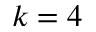Convert formula to latex. <formula><loc_0><loc_0><loc_500><loc_500>k = 4</formula> 